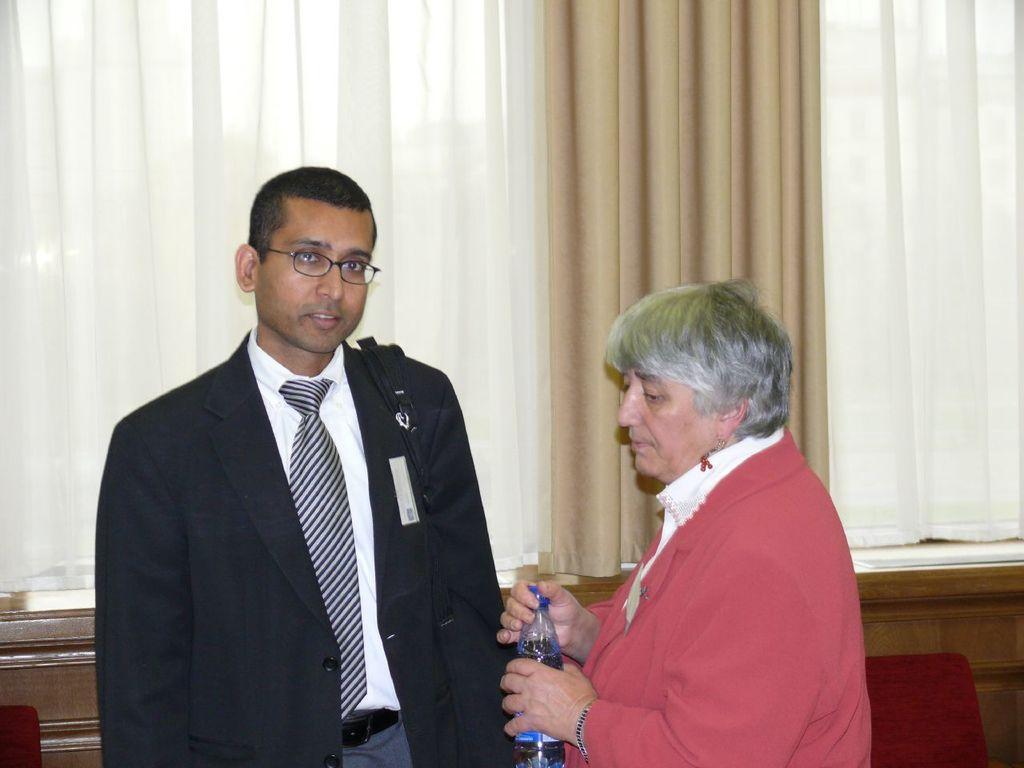Please provide a concise description of this image. A man in suit is posing to camera and beside him, an old woman is standing with a bottle in her hand. 